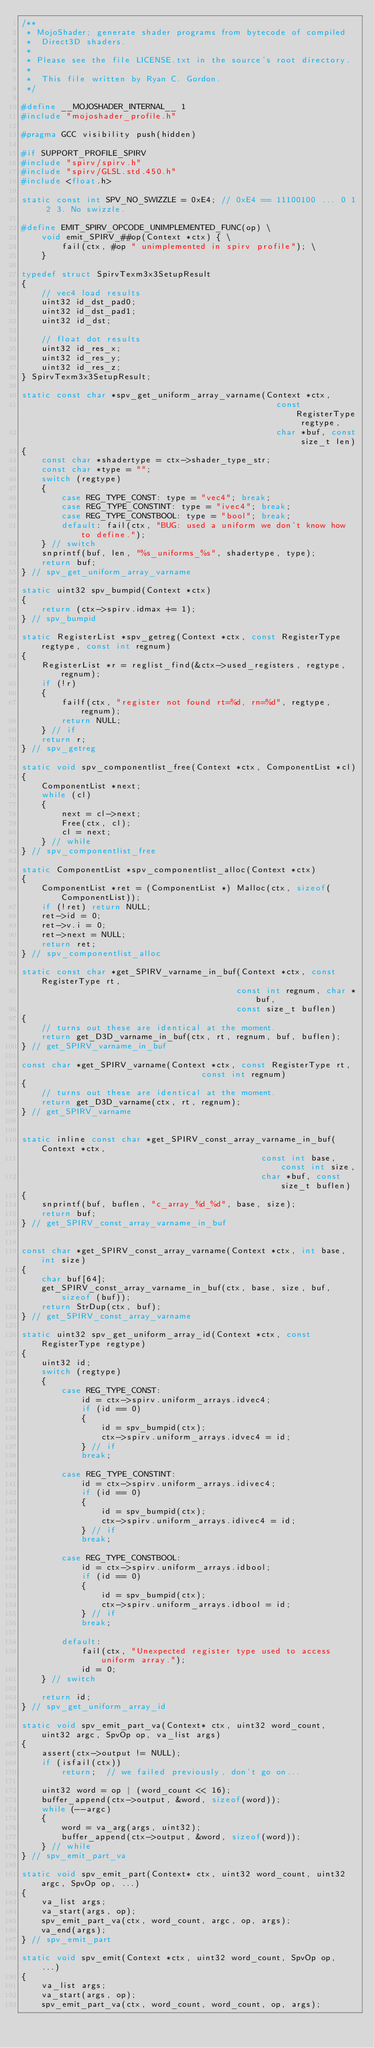<code> <loc_0><loc_0><loc_500><loc_500><_C_>/**
 * MojoShader; generate shader programs from bytecode of compiled
 *  Direct3D shaders.
 *
 * Please see the file LICENSE.txt in the source's root directory.
 *
 *  This file written by Ryan C. Gordon.
 */

#define __MOJOSHADER_INTERNAL__ 1
#include "mojoshader_profile.h"

#pragma GCC visibility push(hidden)

#if SUPPORT_PROFILE_SPIRV
#include "spirv/spirv.h"
#include "spirv/GLSL.std.450.h"
#include <float.h>

static const int SPV_NO_SWIZZLE = 0xE4; // 0xE4 == 11100100 ... 0 1 2 3. No swizzle.

#define EMIT_SPIRV_OPCODE_UNIMPLEMENTED_FUNC(op) \
    void emit_SPIRV_##op(Context *ctx) { \
        fail(ctx, #op " unimplemented in spirv profile"); \
    }

typedef struct SpirvTexm3x3SetupResult
{
    // vec4 load results
    uint32 id_dst_pad0;
    uint32 id_dst_pad1;
    uint32 id_dst;

    // float dot results
    uint32 id_res_x;
    uint32 id_res_y;
    uint32 id_res_z;
} SpirvTexm3x3SetupResult;

static const char *spv_get_uniform_array_varname(Context *ctx,
                                                   const RegisterType regtype,
                                                   char *buf, const size_t len)
{
    const char *shadertype = ctx->shader_type_str;
    const char *type = "";
    switch (regtype)
    {
        case REG_TYPE_CONST: type = "vec4"; break;
        case REG_TYPE_CONSTINT: type = "ivec4"; break;
        case REG_TYPE_CONSTBOOL: type = "bool"; break;
        default: fail(ctx, "BUG: used a uniform we don't know how to define.");
    } // switch
    snprintf(buf, len, "%s_uniforms_%s", shadertype, type);
    return buf;
} // spv_get_uniform_array_varname

static uint32 spv_bumpid(Context *ctx)
{
    return (ctx->spirv.idmax += 1);
} // spv_bumpid

static RegisterList *spv_getreg(Context *ctx, const RegisterType regtype, const int regnum)
{
    RegisterList *r = reglist_find(&ctx->used_registers, regtype, regnum);
    if (!r)
    {
        failf(ctx, "register not found rt=%d, rn=%d", regtype, regnum);
        return NULL;
    } // if
    return r;
} // spv_getreg

static void spv_componentlist_free(Context *ctx, ComponentList *cl)
{
    ComponentList *next;
    while (cl)
    {
        next = cl->next;
        Free(ctx, cl);
        cl = next;
    } // while
} // spv_componentlist_free

static ComponentList *spv_componentlist_alloc(Context *ctx)
{
    ComponentList *ret = (ComponentList *) Malloc(ctx, sizeof(ComponentList));
    if (!ret) return NULL;
    ret->id = 0;
    ret->v.i = 0;
    ret->next = NULL;
    return ret;
} // spv_componentlist_alloc

static const char *get_SPIRV_varname_in_buf(Context *ctx, const RegisterType rt,
                                           const int regnum, char *buf,
                                           const size_t buflen)
{
    // turns out these are identical at the moment.
    return get_D3D_varname_in_buf(ctx, rt, regnum, buf, buflen);
} // get_SPIRV_varname_in_buf

const char *get_SPIRV_varname(Context *ctx, const RegisterType rt,
                                    const int regnum)
{
    // turns out these are identical at the moment.
    return get_D3D_varname(ctx, rt, regnum);
} // get_SPIRV_varname


static inline const char *get_SPIRV_const_array_varname_in_buf(Context *ctx,
                                                const int base, const int size,
                                                char *buf, const size_t buflen)
{
    snprintf(buf, buflen, "c_array_%d_%d", base, size);
    return buf;
} // get_SPIRV_const_array_varname_in_buf


const char *get_SPIRV_const_array_varname(Context *ctx, int base, int size)
{
    char buf[64];
    get_SPIRV_const_array_varname_in_buf(ctx, base, size, buf, sizeof (buf));
    return StrDup(ctx, buf);
} // get_SPIRV_const_array_varname

static uint32 spv_get_uniform_array_id(Context *ctx, const RegisterType regtype)
{
    uint32 id;
    switch (regtype)
    {
        case REG_TYPE_CONST:
            id = ctx->spirv.uniform_arrays.idvec4;
            if (id == 0)
            {
                id = spv_bumpid(ctx);
                ctx->spirv.uniform_arrays.idvec4 = id;
            } // if
            break;

        case REG_TYPE_CONSTINT:
            id = ctx->spirv.uniform_arrays.idivec4;
            if (id == 0)
            {
                id = spv_bumpid(ctx);
                ctx->spirv.uniform_arrays.idivec4 = id;
            } // if
            break;

        case REG_TYPE_CONSTBOOL:
            id = ctx->spirv.uniform_arrays.idbool;
            if (id == 0)
            {
                id = spv_bumpid(ctx);
                ctx->spirv.uniform_arrays.idbool = id;
            } // if
            break;

        default:
            fail(ctx, "Unexpected register type used to access uniform array.");
            id = 0;
    } // switch

    return id;
} // spv_get_uniform_array_id

static void spv_emit_part_va(Context* ctx, uint32 word_count, uint32 argc, SpvOp op, va_list args)
{
    assert(ctx->output != NULL);
    if (isfail(ctx))
        return;  // we failed previously, don't go on...

    uint32 word = op | (word_count << 16);
    buffer_append(ctx->output, &word, sizeof(word));
    while (--argc)
    {
        word = va_arg(args, uint32);
        buffer_append(ctx->output, &word, sizeof(word));
    } // while
} // spv_emit_part_va

static void spv_emit_part(Context* ctx, uint32 word_count, uint32 argc, SpvOp op, ...)
{
    va_list args;
    va_start(args, op);
    spv_emit_part_va(ctx, word_count, argc, op, args);
    va_end(args);
} // spv_emit_part

static void spv_emit(Context *ctx, uint32 word_count, SpvOp op, ...)
{
    va_list args;
    va_start(args, op);
    spv_emit_part_va(ctx, word_count, word_count, op, args);</code> 